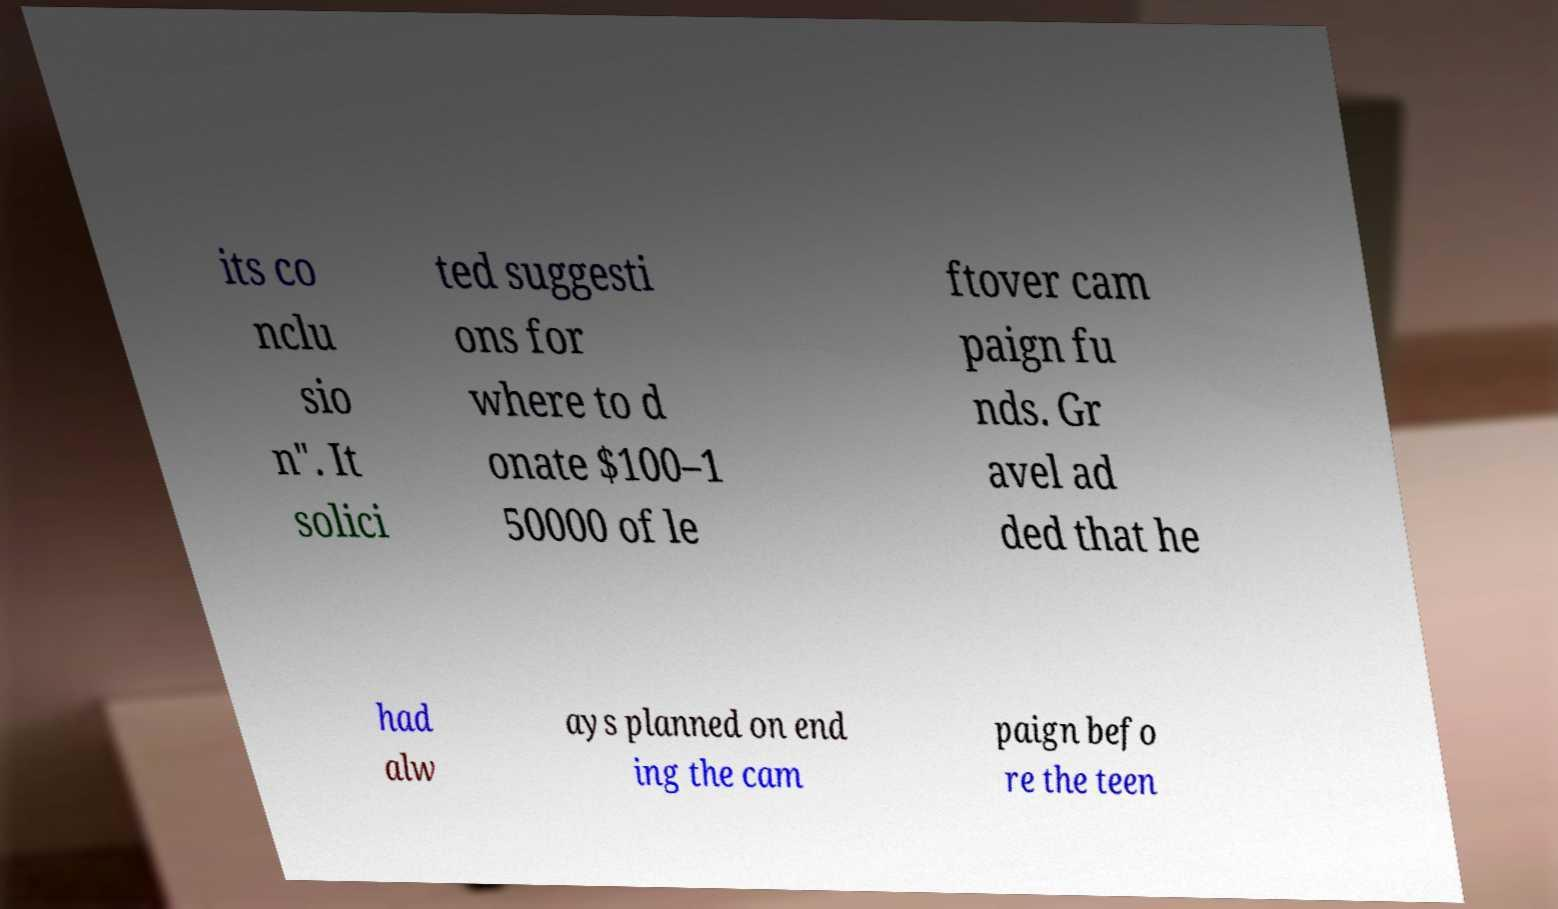What messages or text are displayed in this image? I need them in a readable, typed format. its co nclu sio n". It solici ted suggesti ons for where to d onate $100–1 50000 of le ftover cam paign fu nds. Gr avel ad ded that he had alw ays planned on end ing the cam paign befo re the teen 